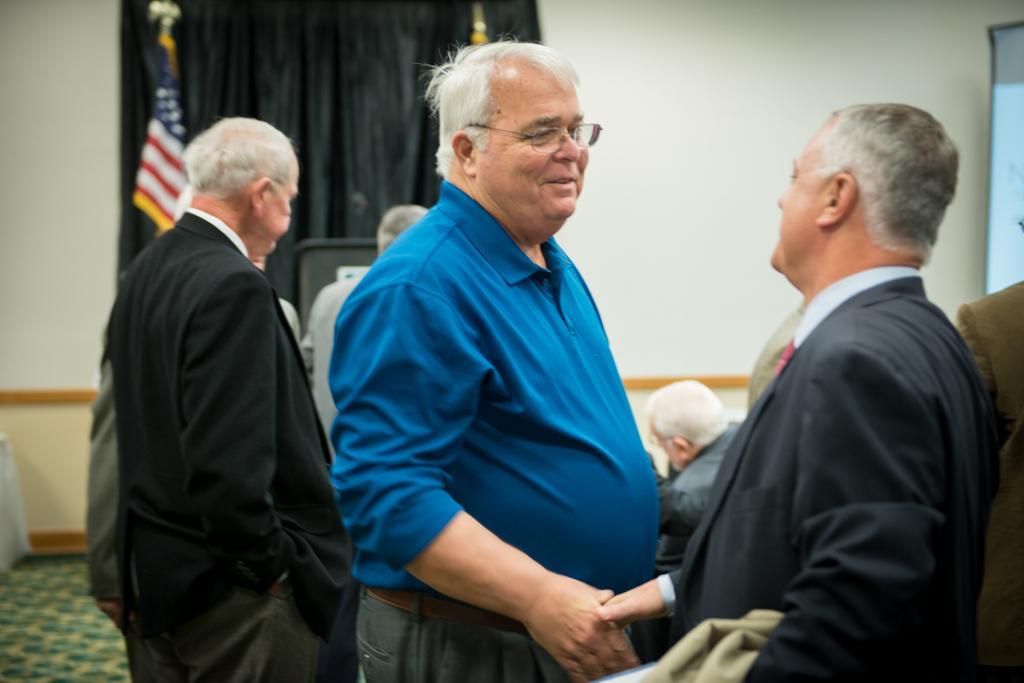In one or two sentences, can you explain what this image depicts? In a room there are a group of men, in the front two men were greeting each other and in the background there is a black curtain, a flag and a wall. 